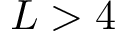Convert formula to latex. <formula><loc_0><loc_0><loc_500><loc_500>L > 4</formula> 